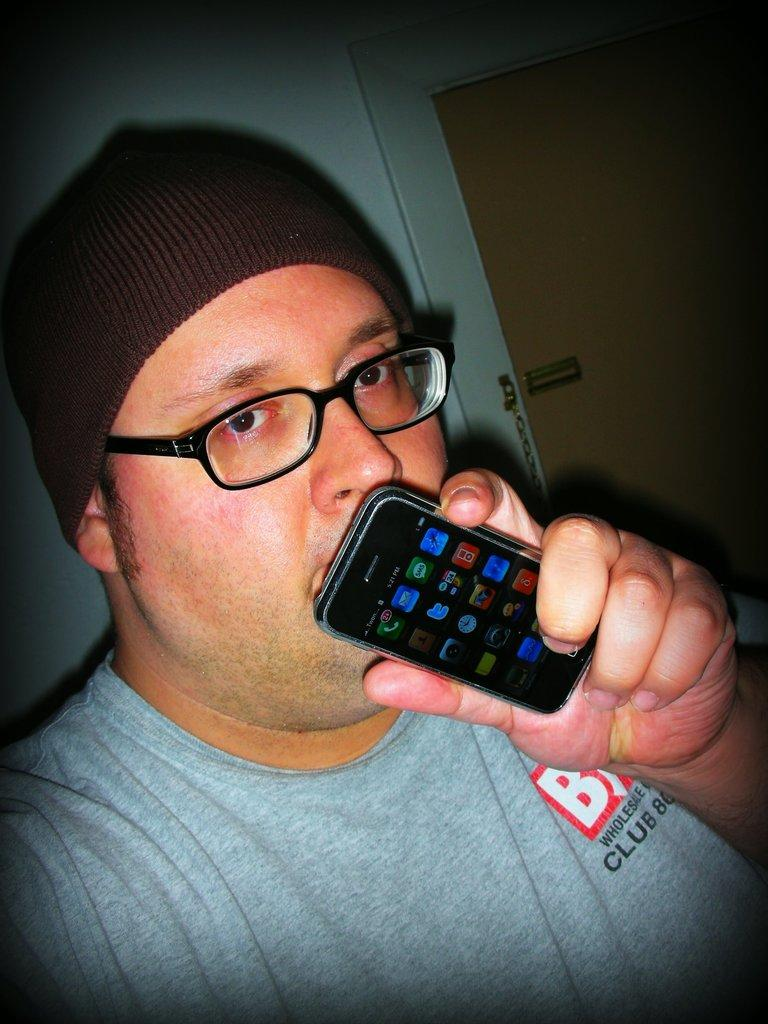What is the main subject of the image? There is a man in the image. What is the man doing in the image? The man is standing in the image. What object is the man holding in his hand? The man is holding a mobile phone in his hand. What type of bomb can be seen in the man's hand in the image? There is no bomb present in the image; the man is holding a mobile phone. What color is the man's eye in the image? The image does not show the man's eye, so it cannot be determined from the image. 